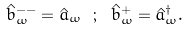Convert formula to latex. <formula><loc_0><loc_0><loc_500><loc_500>\hat { b } _ { \omega } ^ { - - } = \hat { a } _ { \omega } \ ; \ \hat { b } _ { \omega } ^ { + } = \hat { a } _ { \omega } ^ { \dagger } .</formula> 